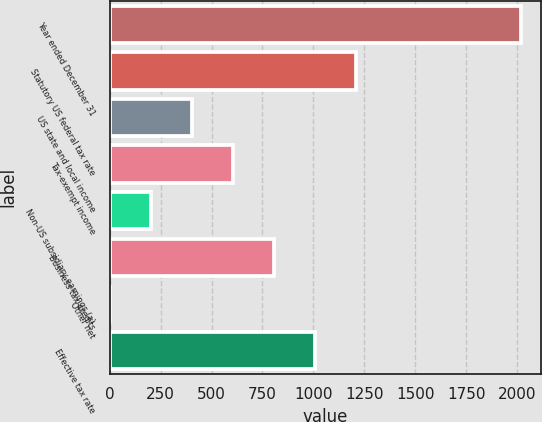Convert chart. <chart><loc_0><loc_0><loc_500><loc_500><bar_chart><fcel>Year ended December 31<fcel>Statutory US federal tax rate<fcel>US state and local income<fcel>Tax-exempt income<fcel>Non-US subsidiary earnings (a)<fcel>Business tax credits<fcel>Other net<fcel>Effective tax rate<nl><fcel>2016<fcel>1209.84<fcel>403.68<fcel>605.22<fcel>202.14<fcel>806.76<fcel>0.6<fcel>1008.3<nl></chart> 